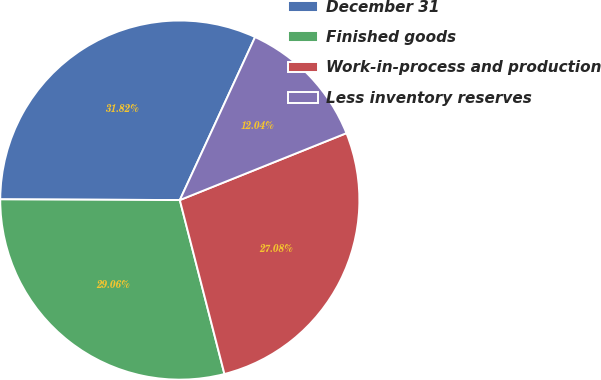Convert chart to OTSL. <chart><loc_0><loc_0><loc_500><loc_500><pie_chart><fcel>December 31<fcel>Finished goods<fcel>Work-in-process and production<fcel>Less inventory reserves<nl><fcel>31.82%<fcel>29.06%<fcel>27.08%<fcel>12.04%<nl></chart> 